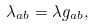Convert formula to latex. <formula><loc_0><loc_0><loc_500><loc_500>\lambda _ { a b } = \lambda g _ { a b } ,</formula> 